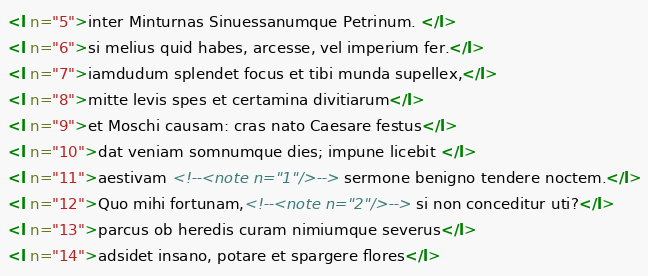Convert code to text. <code><loc_0><loc_0><loc_500><loc_500><_XML_><l n="5">inter Minturnas Sinuessanumque Petrinum. </l>
<l n="6">si melius quid habes, arcesse, vel imperium fer.</l>
<l n="7">iamdudum splendet focus et tibi munda supellex,</l>
<l n="8">mitte levis spes et certamina divitiarum</l>
<l n="9">et Moschi causam: cras nato Caesare festus</l>
<l n="10">dat veniam somnumque dies; impune licebit </l>
<l n="11">aestivam <!--<note n="1"/>--> sermone benigno tendere noctem.</l>
<l n="12">Quo mihi fortunam,<!--<note n="2"/>--> si non conceditur uti?</l>
<l n="13">parcus ob heredis curam nimiumque severus</l>
<l n="14">adsidet insano, potare et spargere flores</l></code> 